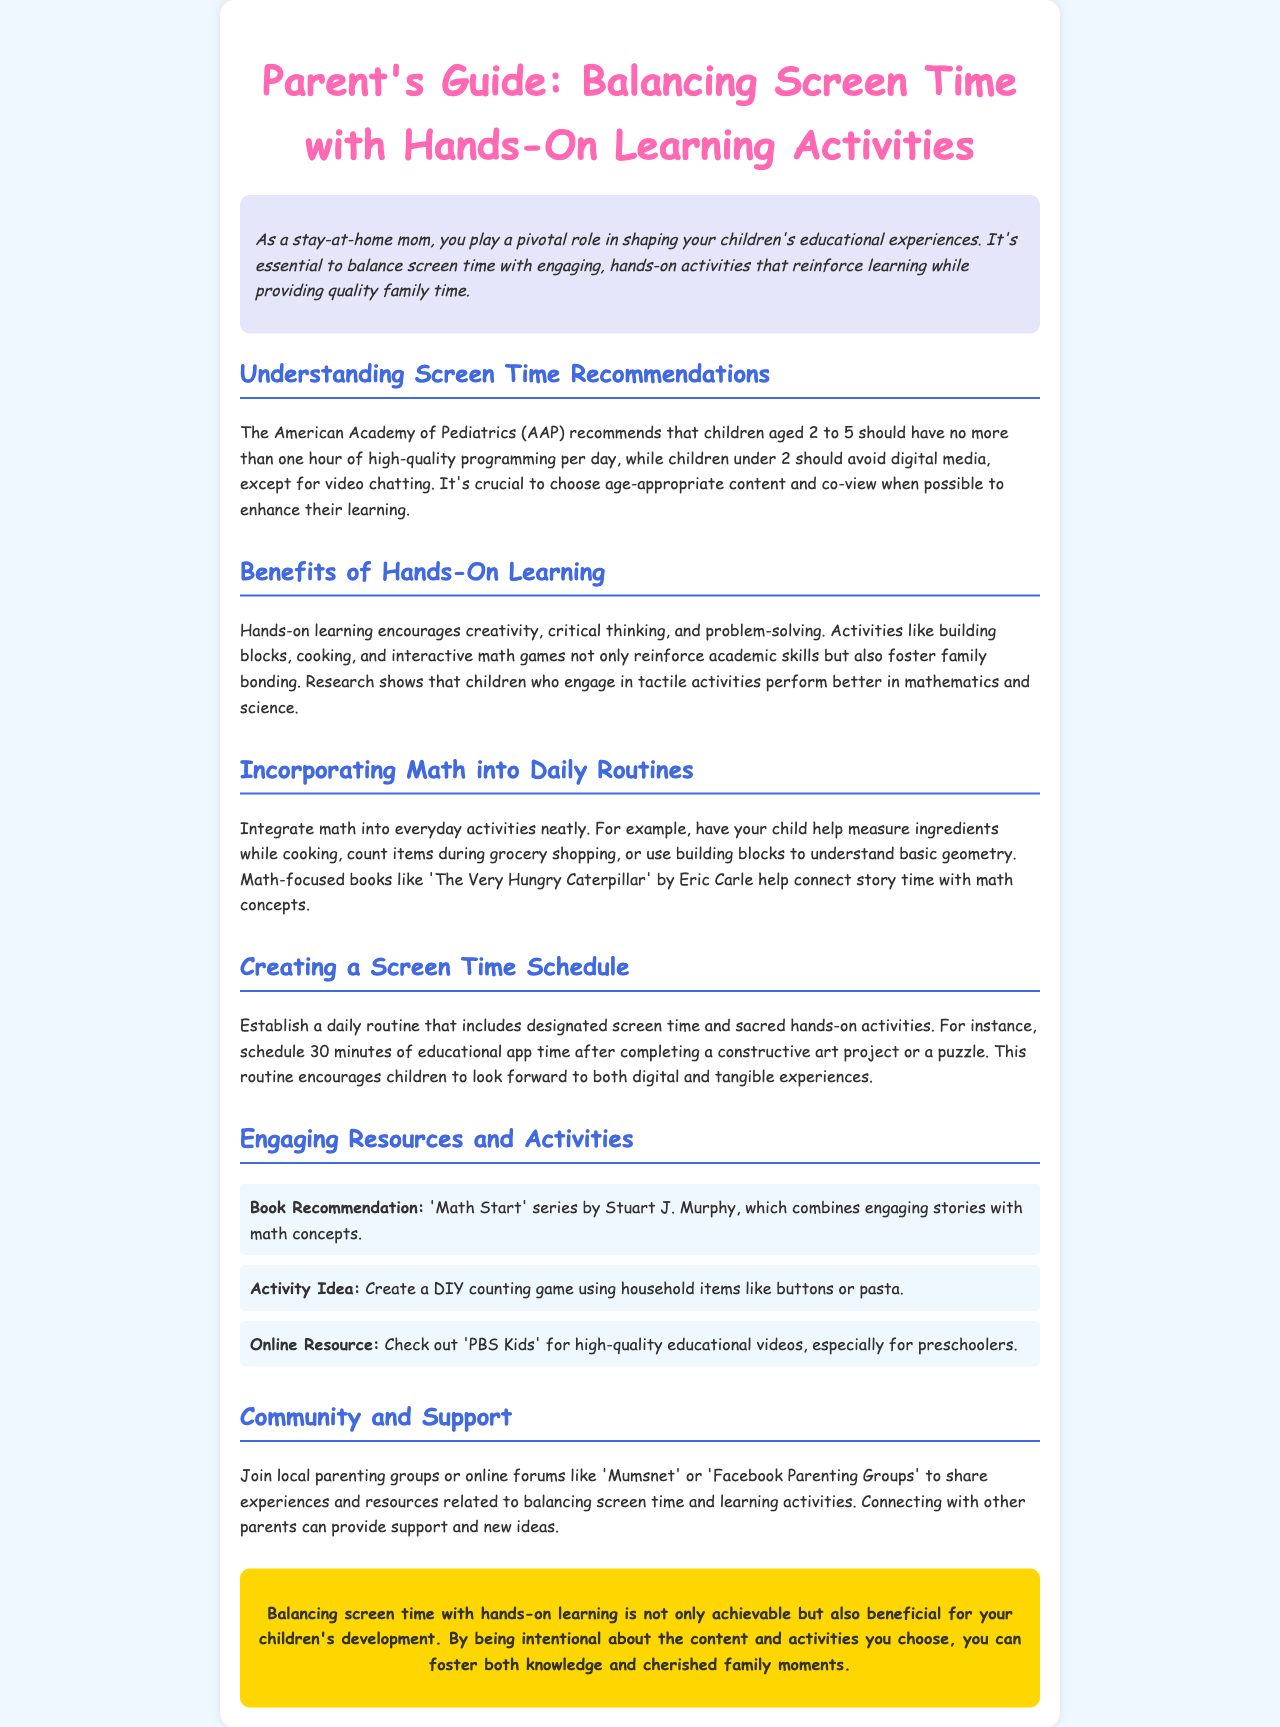What is the recommended screen time for children aged 2 to 5? The document states that children aged 2 to 5 should have no more than one hour of high-quality programming per day.
Answer: one hour What age should children avoid digital media? The newsletter mentions that children under 2 should avoid digital media.
Answer: under 2 What is a benefit of hands-on learning? According to the document, hands-on learning encourages creativity, critical thinking, and problem-solving.
Answer: creativity What is one way to incorporate math into daily routines? The document suggests having your child help measure ingredients while cooking as a way to incorporate math.
Answer: measuring ingredients What is a recommended book for math concepts? The document recommends the 'Math Start' series by Stuart J. Murphy for engaging stories with math concepts.
Answer: 'Math Start' series What online resource does the document suggest for educational videos? The newsletter recommends checking out 'PBS Kids' for high-quality educational videos.
Answer: PBS Kids What should be scheduled after completing a constructive art project? The document suggests scheduling 30 minutes of educational app time after completing a constructive art project.
Answer: educational app time Which community platform is mentioned for parental support? The document refers to 'Mumsnet' as a community platform for sharing experiences and resources.
Answer: Mumsnet 